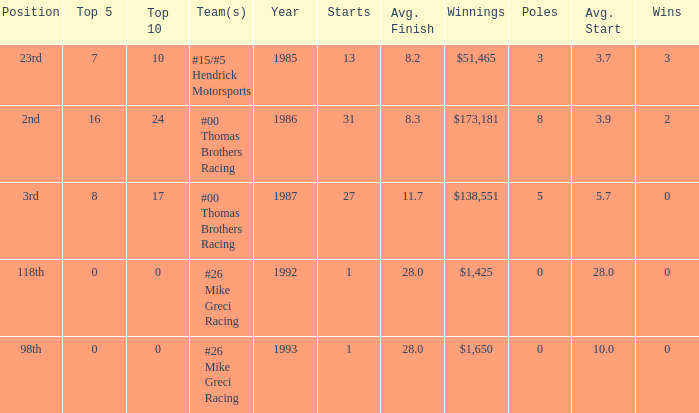How many years did he have an average finish of 11.7? 1.0. 